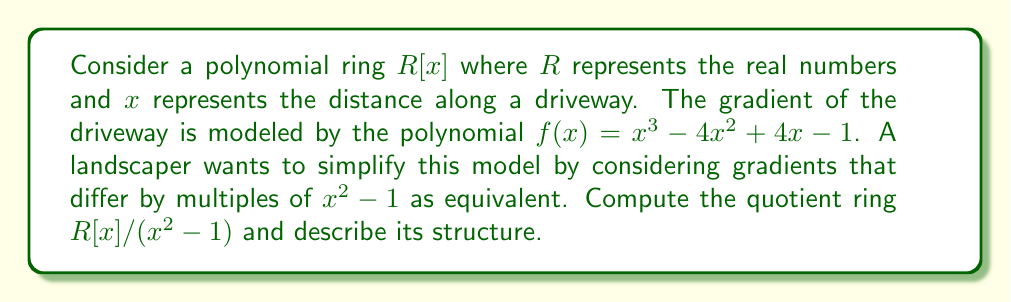Could you help me with this problem? To compute the quotient ring $R[x]/(x^2-1)$, we follow these steps:

1) In the quotient ring $R[x]/(x^2-1)$, we consider polynomials equivalent if they differ by a multiple of $x^2-1$. This means $x^2 \equiv 1$ in this ring.

2) Any polynomial in $R[x]$ can be written uniquely as:

   $a(x)(x^2-1) + bx + c$, where $a(x)$ is some polynomial and $b,c \in R$.

3) In the quotient ring, all multiples of $x^2-1$ become zero, so each element of $R[x]/(x^2-1)$ can be uniquely represented by a polynomial of the form $bx + c$, where $b,c \in R$.

4) Addition in this ring is straightforward:
   $(b_1x + c_1) + (b_2x + c_2) = (b_1+b_2)x + (c_1+c_2)$

5) Multiplication is more interesting:
   $(b_1x + c_1)(b_2x + c_2) = b_1b_2x^2 + (b_1c_2+b_2c_1)x + c_1c_2$
   But since $x^2 \equiv 1$, this simplifies to:
   $(b_1b_2 + b_1c_2+b_2c_1)x + (b_1b_2 + c_1c_2)$

6) This ring structure is isomorphic to the ring of 2x2 real matrices of the form:
   $$\begin{pmatrix} c & b \\ b & c \end{pmatrix}$$
   where $bx + c$ corresponds to the matrix above.

This quotient ring models how the landscaper can simplify gradient calculations by considering gradients that differ by multiples of $x^2-1$ as equivalent, which could represent a standardization of driveway slope changes over distance.
Answer: The quotient ring $R[x]/(x^2-1)$ consists of elements of the form $bx + c$ where $b,c \in R$. It is isomorphic to the ring of 2x2 real matrices of the form $\begin{pmatrix} c & b \\ b & c \end{pmatrix}$. 